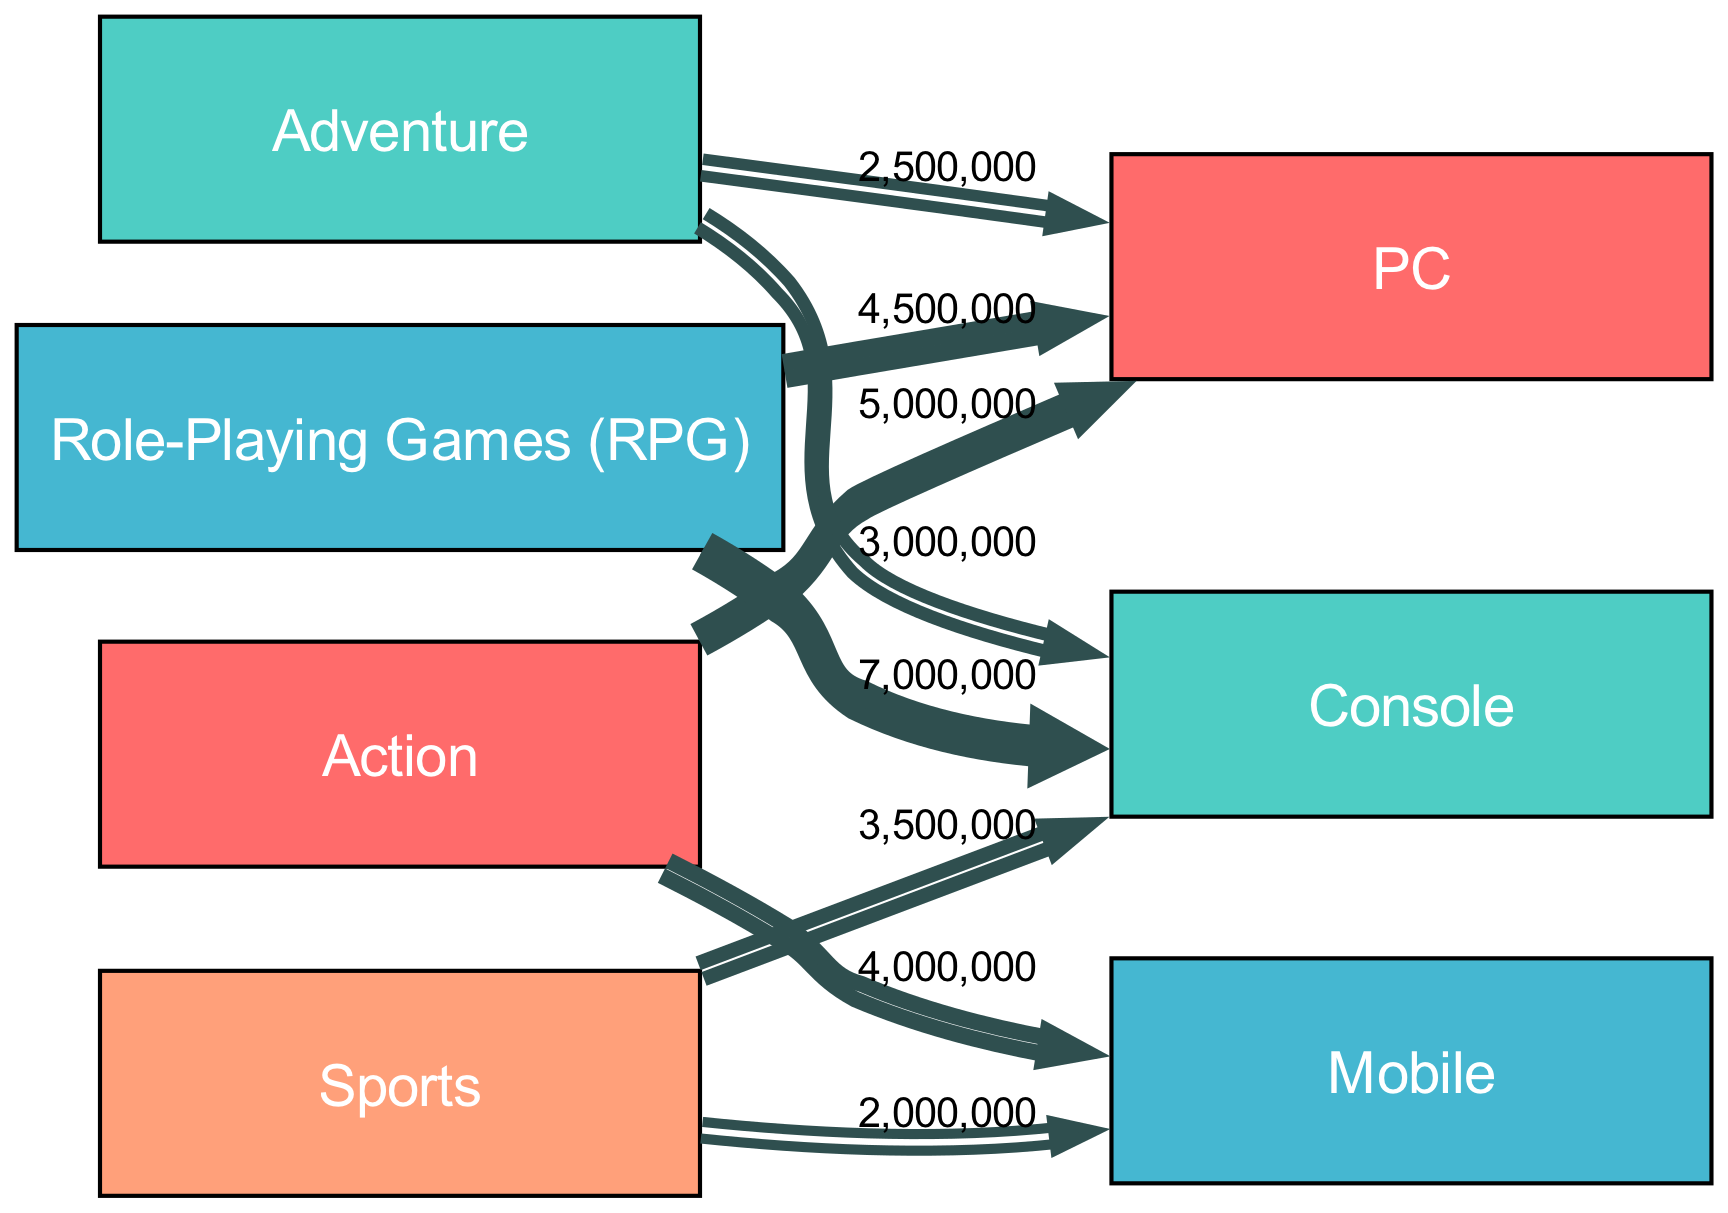What is the total sales value for Action games on PC? According to the links in the diagram, Action games on PC have a sales value of 5,000,000.
Answer: 5,000,000 Which genre has the highest sales on Console? The RPG genre has the highest sales on Console with a value of 7,000,000.
Answer: 7,000,000 How many total nodes are present in the diagram? The diagram has a total of 7 nodes: Action, Adventure, RPG, Sports, PC, Console, and Mobile.
Answer: 7 What is the sales value for Sports games on Mobile? The sales value for Sports games on Mobile is 2,000,000, as indicated by the corresponding link in the diagram.
Answer: 2,000,000 Which genre connects to both PC and Mobile? The Action genre connects to both PC and Mobile, with sales values of 5,000,000 and 4,000,000, respectively.
Answer: Action What is the combined sales value for RPG across both platforms? RPG has sales on Console (7,000,000) and PC (4,500,000). Combining these gives us a total of 11,500,000 in sales value.
Answer: 11,500,000 Which platform has the lowest total sales? The Mobile platform has the lowest total sales when considering the values from all connected genres, with a total of 6,000,000 (4,000,000 from Action and 2,000,000 from Sports).
Answer: Mobile What relationship exists between the Sports genre and Console? The Sports genre connects to the Console with a sales value of 3,500,000, indicating significant sales for that genre on that platform.
Answer: 3,500,000 What is the highest sales value recorded in the diagram? The highest sales value recorded in the diagram is 7,000,000, attributed to RPG on the Console platform.
Answer: 7,000,000 